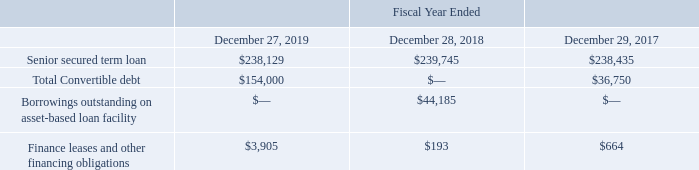Indebtedness
The following table presents selected financial information on our indebtedness (in thousands):
As of December 27, 2019, we have various floating- and fixed-rate debt instruments with varying maturities for an aggregate principal amount of $392.1 million. See Note 9 “Debt Obligations” to our consolidated financial statements for a full description of our debt instruments.
On November 22, 2019, we issued $150.0 million aggregate principal amount of 1.875% Convertible Senior Notes (the “Senior Notes”). Approximately $43.2 million of the net proceeds were used to repay all outstanding borrowings then outstanding under our ABL and we intend to use the remainder for working capital and general corporate purposes, which may include future acquisitions.
On July 25, 2018, the holders of the $36.8 million principal amount of convertible subordinated notes that were issued in connection with our acquisition of Del Monte converted these notes and related accrued interest of $0.3 million into 1,246,272 shares of the Company’s common stock.
On June 29, 2018, we entered into an asset-based loan facility (“ABL”) that increased our borrowing capacity from $75.0 million to $150.0 million. Additionally, we reduced the fixed-rate portion of interest charged on our senior secured term loan (“Term Loan”) from 475 basis points to 350 basis points over Adjusted LIBOR as a result of repricings executed on December 14, 2017 and November 16, 2018.
A portion of the interest rate charged on our Term Loan is currently based on LIBOR and, at our option, a component of the interest charged on the borrowings outstanding on our ABL, if any, may bear interest rates based on LIBOR. LIBOR has been the subject of reform and is expected to phase out by the end of fiscal 2021. The consequences of the discontinuation of LIBOR cannot be entirely predicted but could impact the interest expense we incur on these debt instruments. We will negotiate alternatives to LIBOR with our lenders before LIBOR ceases to be a widely available reference rate.
What is the value of senior secured term loan for fiscal years 2019 and 2018 respectively?
Answer scale should be: thousand. $238,129, $239,745. What is the value of finance leases and other financing obligations for fiscal years 2019 and 2018 respectively?
Answer scale should be: thousand. $3,905, $193. What is the value of total convertible debt in fiscal year 2019?
Answer scale should be: thousand. $154,000. What is the percentage change in the finance leases and other financing obligations between fiscal years 2018 and 2019?
Answer scale should be: percent. (3,905-193)/193
Answer: 1923.32. Which fiscal year has a higher value of senior secured term loan? Look at COL3 to COL5 , and compare the values in Row 3
Answer: 2018. What is the average finance leases and other financing obligations for fiscal years 2018 and 2019?
Answer scale should be: thousand. (3,905+ 193)/2
Answer: 2049. 